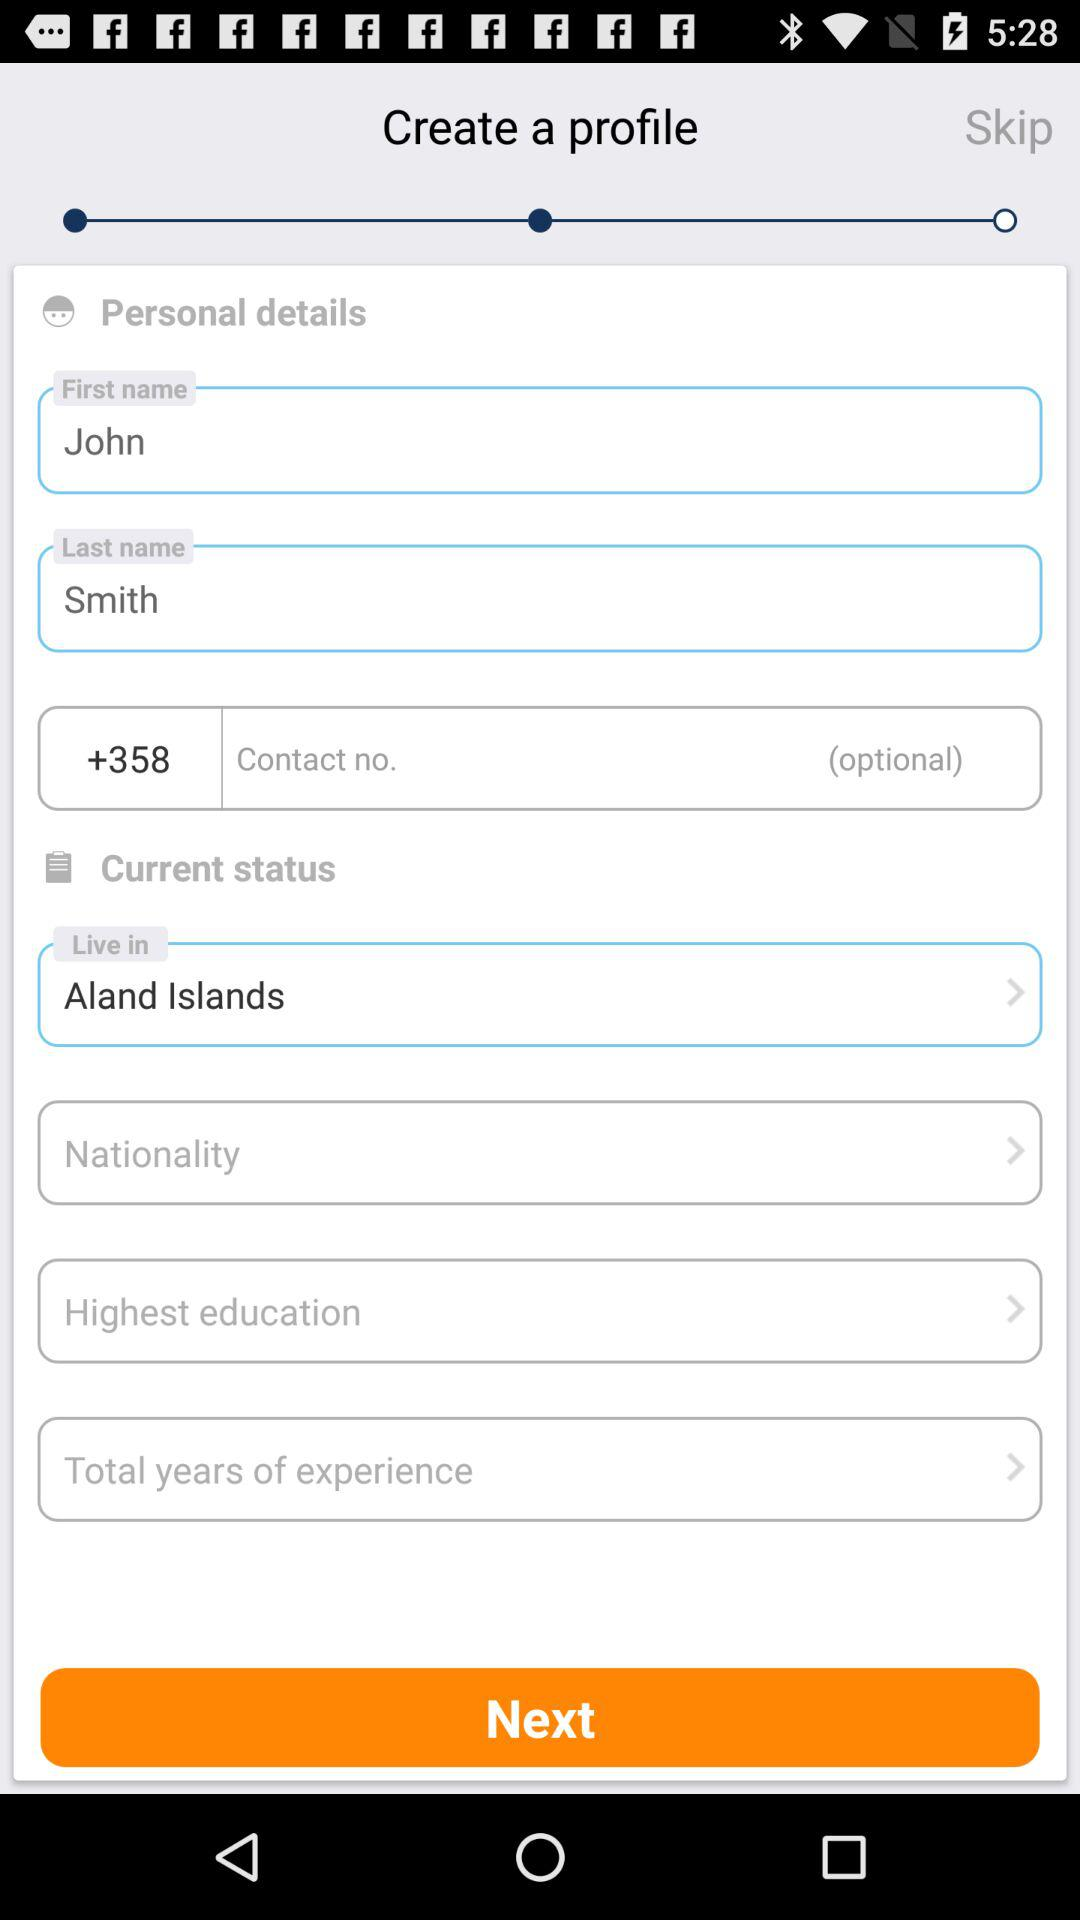What is the current place to live in? The current place to live in is "Aland Islands". 